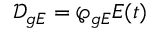<formula> <loc_0><loc_0><loc_500><loc_500>\mathcal { D } _ { g E } = \wp _ { g E } E ( t )</formula> 